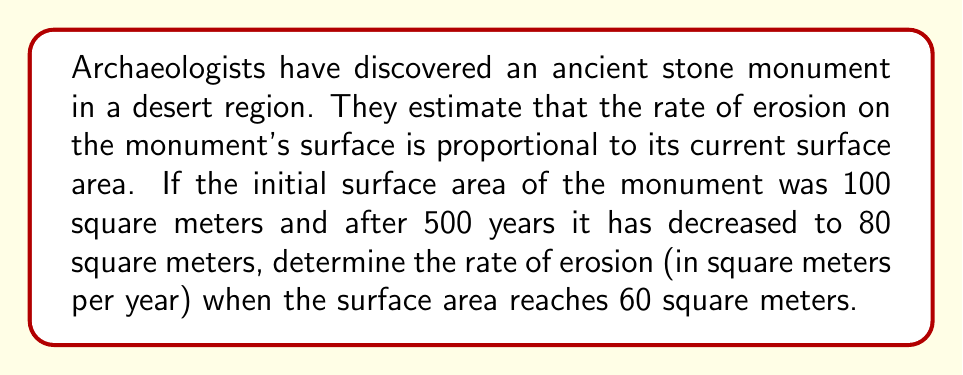What is the answer to this math problem? Let's approach this problem step-by-step using a first-order differential equation:

1) Let $A(t)$ be the surface area of the monument at time $t$ in years.

2) The rate of change of the surface area is proportional to the current surface area:

   $$\frac{dA}{dt} = -kA$$

   where $k$ is the proportionality constant (erosion rate coefficient).

3) This is a separable differential equation. We can solve it as follows:

   $$\int \frac{dA}{A} = -k \int dt$$

   $$\ln A = -kt + C$$

   $$A = Ce^{-kt}$$

4) Using the initial condition $A(0) = 100$, we find $C = 100$.

   $$A = 100e^{-kt}$$

5) Now, we can use the condition that after 500 years, the area is 80 square meters:

   $$80 = 100e^{-500k}$$

   $$\ln(0.8) = -500k$$

   $$k = \frac{-\ln(0.8)}{500} \approx 0.000446$$

6) The general solution for the surface area at time $t$ is:

   $$A(t) = 100e^{-0.000446t}$$

7) To find when the area reaches 60 square meters, we solve:

   $$60 = 100e^{-0.000446t}$$

   $$t = \frac{\ln(0.6)}{-0.000446} \approx 1145.6 \text{ years}$$

8) The rate of erosion at this point is given by:

   $$\frac{dA}{dt} = -kA = -0.000446 \cdot 60 \approx -0.02676 \text{ square meters per year}$$
Answer: The rate of erosion when the surface area reaches 60 square meters is approximately 0.02676 square meters per year. 